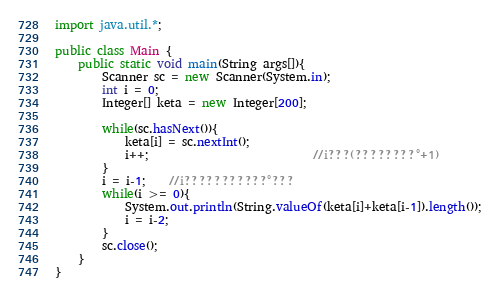Convert code to text. <code><loc_0><loc_0><loc_500><loc_500><_Java_>import java.util.*;

public class Main {
	public static void main(String args[]){
		Scanner sc = new Scanner(System.in);
		int i = 0;
		Integer[] keta = new Integer[200];
		
		while(sc.hasNext()){
			keta[i] = sc.nextInt();
			i++;							//i???(????????°+1)
		}
		i = i-1;	//i???????????°???
		while(i >= 0){
			System.out.println(String.valueOf(keta[i]+keta[i-1]).length());
			i = i-2;
		}
		sc.close();
	}
}</code> 